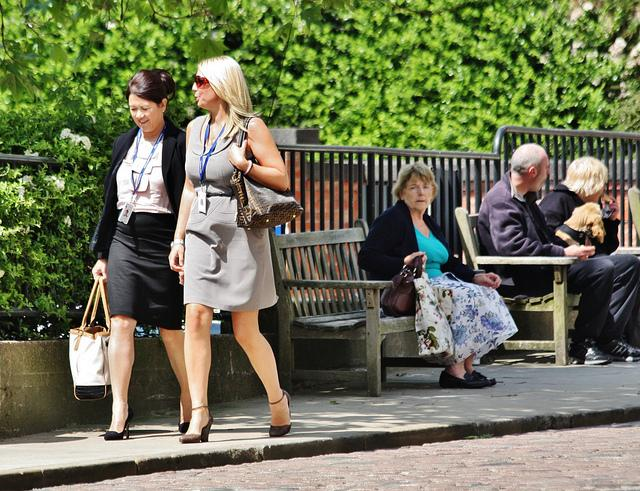Where are they likely to work from? office 